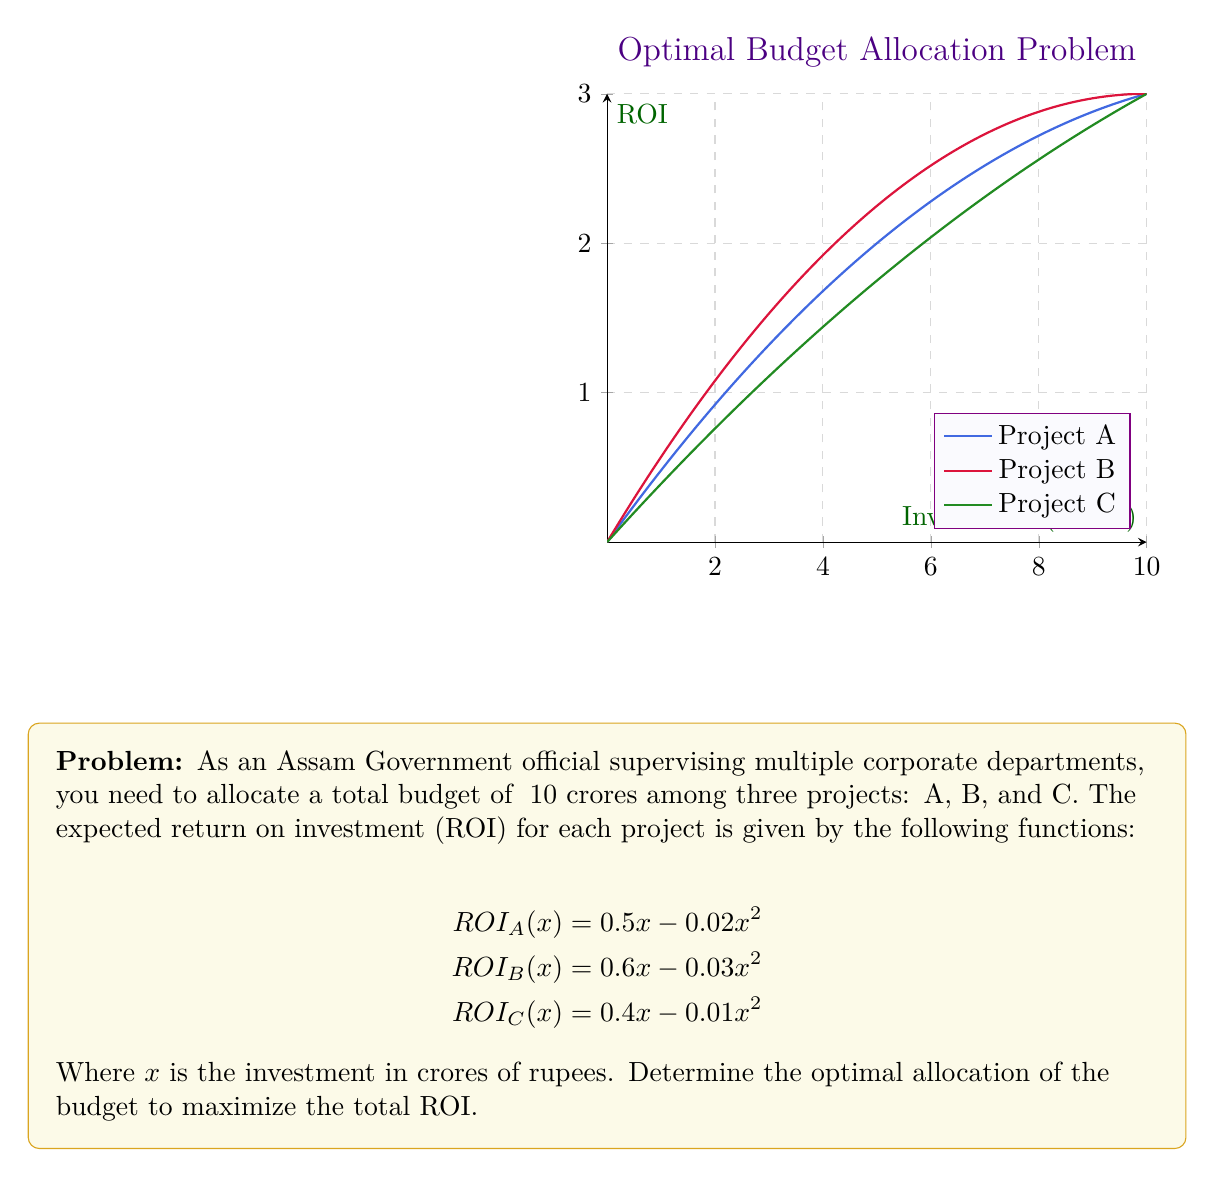Can you solve this math problem? To solve this optimization problem, we'll use the method of Lagrange multipliers:

1) Let $x$, $y$, and $z$ be the investments in projects A, B, and C respectively.

2) Our objective function is:
   $$f(x,y,z) = (0.5x - 0.02x^2) + (0.6y - 0.03y^2) + (0.4z - 0.01z^2)$$

3) The constraint is:
   $$g(x,y,z) = x + y + z - 10 = 0$$

4) Form the Lagrangian:
   $$L(x,y,z,\lambda) = f(x,y,z) - \lambda g(x,y,z)$$

5) Take partial derivatives and set them to zero:
   $$\begin{align*}
   \frac{\partial L}{\partial x} &= 0.5 - 0.04x - \lambda = 0 \\
   \frac{\partial L}{\partial y} &= 0.6 - 0.06y - \lambda = 0 \\
   \frac{\partial L}{\partial z} &= 0.4 - 0.02z - \lambda = 0 \\
   \frac{\partial L}{\partial \lambda} &= x + y + z - 10 = 0
   \end{align*}$$

6) From these equations:
   $$\begin{align*}
   x &= \frac{0.5 - \lambda}{0.04} \\
   y &= \frac{0.6 - \lambda}{0.06} \\
   z &= \frac{0.4 - \lambda}{0.02}
   \end{align*}$$

7) Substitute into the constraint equation:
   $$\frac{0.5 - \lambda}{0.04} + \frac{0.6 - \lambda}{0.06} + \frac{0.4 - \lambda}{0.02} = 10$$

8) Solve for $\lambda$:
   $$\lambda \approx 0.2$$

9) Substitute back to find $x$, $y$, and $z$:
   $$\begin{align*}
   x &\approx 7.5 \\
   y &\approx 6.67 \\
   z &\approx 10
   \end{align*}$$

10) Since $z > 10$, we need to adjust our solution. Set $z = 10$ and recalculate:
    $$\begin{align*}
    x &\approx 3.75 \\
    y &\approx 6.25 \\
    z &= 10
    \end{align*}$$

Therefore, the optimal allocation is approximately ₹3.75 crores to Project A, ₹6.25 crores to Project B, and ₹0 to Project C.
Answer: Project A: ₹3.75 crores, Project B: ₹6.25 crores, Project C: ₹0 